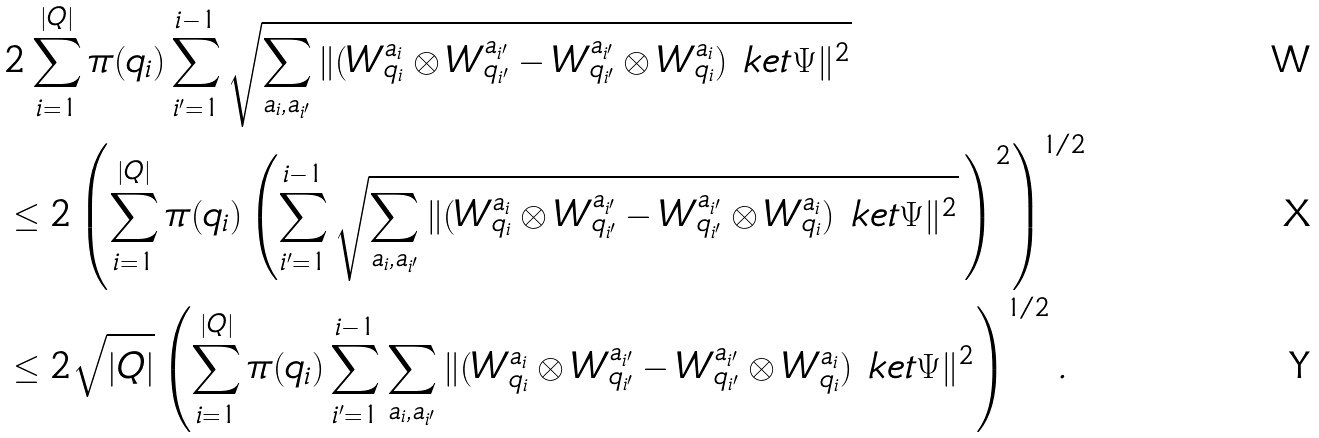<formula> <loc_0><loc_0><loc_500><loc_500>& 2 \sum _ { i = 1 } ^ { | Q | } \pi ( q _ { i } ) \sum _ { i ^ { \prime } = 1 } ^ { i - 1 } \sqrt { \sum _ { a _ { i } , a _ { i ^ { \prime } } } \| ( W _ { q _ { i } } ^ { a _ { i } } \otimes W _ { q _ { i ^ { \prime } } } ^ { a _ { i ^ { \prime } } } - W _ { q _ { i ^ { \prime } } } ^ { a _ { i ^ { \prime } } } \otimes W _ { q _ { i } } ^ { a _ { i } } ) \ k e t { \Psi } \| ^ { 2 } } \\ & \leq 2 \left ( \sum _ { i = 1 } ^ { | Q | } \pi ( q _ { i } ) \left ( \sum _ { i ^ { \prime } = 1 } ^ { i - 1 } \sqrt { \sum _ { a _ { i } , a _ { i ^ { \prime } } } \| ( W _ { q _ { i } } ^ { a _ { i } } \otimes W _ { q _ { i ^ { \prime } } } ^ { a _ { i ^ { \prime } } } - W _ { q _ { i ^ { \prime } } } ^ { a _ { i ^ { \prime } } } \otimes W _ { q _ { i } } ^ { a _ { i } } ) \ k e t { \Psi } \| ^ { 2 } } \, \right ) ^ { 2 } \right ) ^ { 1 / 2 } \\ & \leq 2 \sqrt { | Q | } \left ( \sum _ { i = 1 } ^ { | Q | } \pi ( q _ { i } ) \sum _ { i ^ { \prime } = 1 } ^ { i - 1 } \sum _ { a _ { i } , a _ { i ^ { \prime } } } \| ( W _ { q _ { i } } ^ { a _ { i } } \otimes W _ { q _ { i ^ { \prime } } } ^ { a _ { i ^ { \prime } } } - W _ { q _ { i ^ { \prime } } } ^ { a _ { i ^ { \prime } } } \otimes W _ { q _ { i } } ^ { a _ { i } } ) \ k e t { \Psi } \| ^ { 2 } \right ) ^ { 1 / 2 } .</formula> 